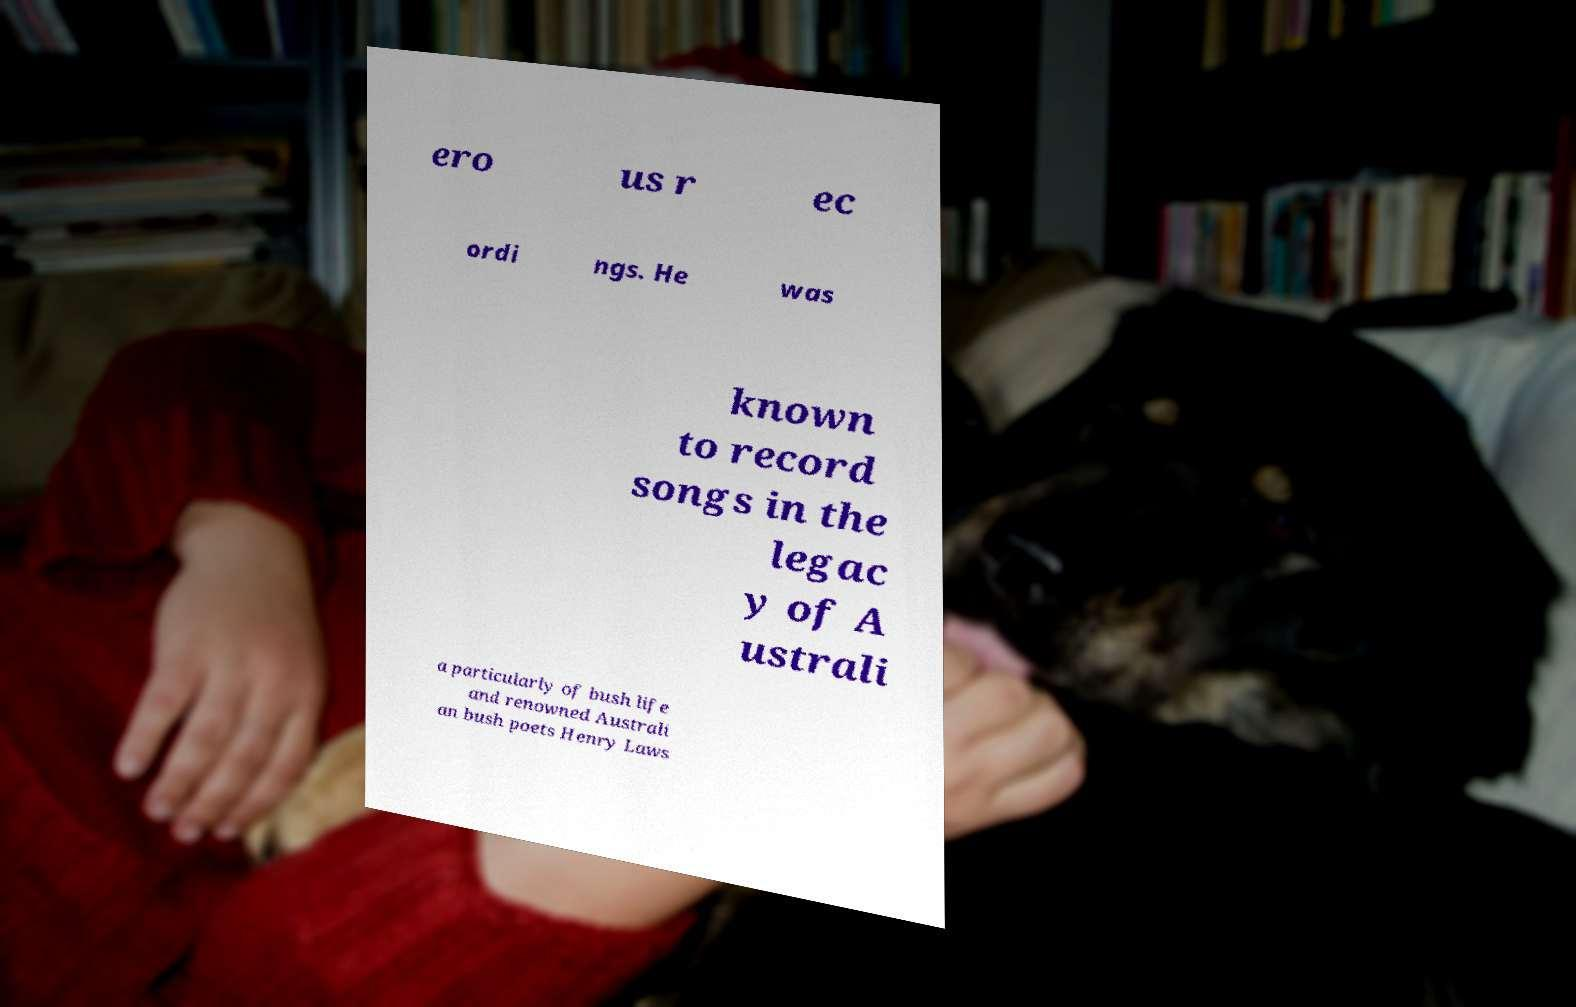Could you assist in decoding the text presented in this image and type it out clearly? ero us r ec ordi ngs. He was known to record songs in the legac y of A ustrali a particularly of bush life and renowned Australi an bush poets Henry Laws 